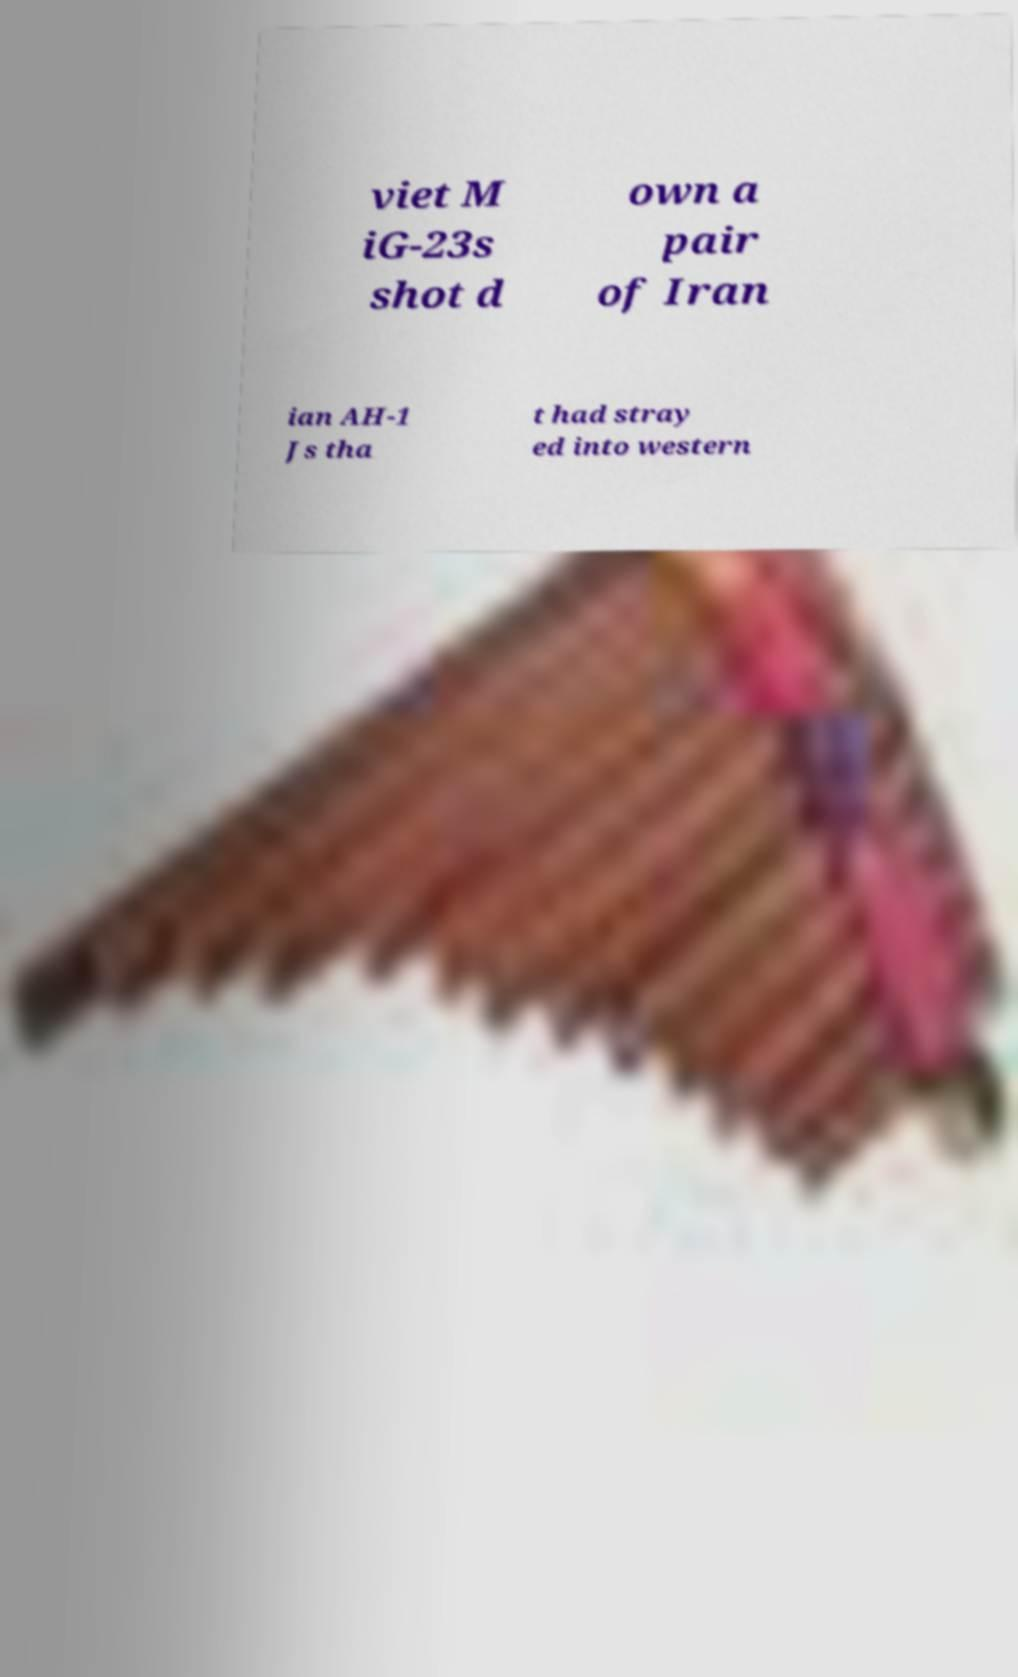Please read and relay the text visible in this image. What does it say? viet M iG-23s shot d own a pair of Iran ian AH-1 Js tha t had stray ed into western 